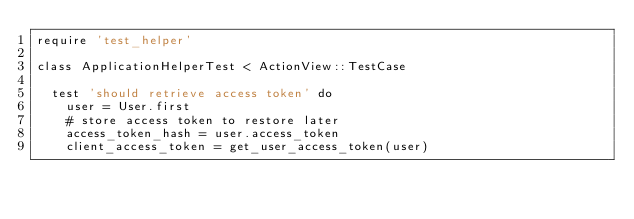Convert code to text. <code><loc_0><loc_0><loc_500><loc_500><_Ruby_>require 'test_helper'

class ApplicationHelperTest < ActionView::TestCase

  test 'should retrieve access token' do
    user = User.first
    # store access token to restore later
    access_token_hash = user.access_token
    client_access_token = get_user_access_token(user)</code> 